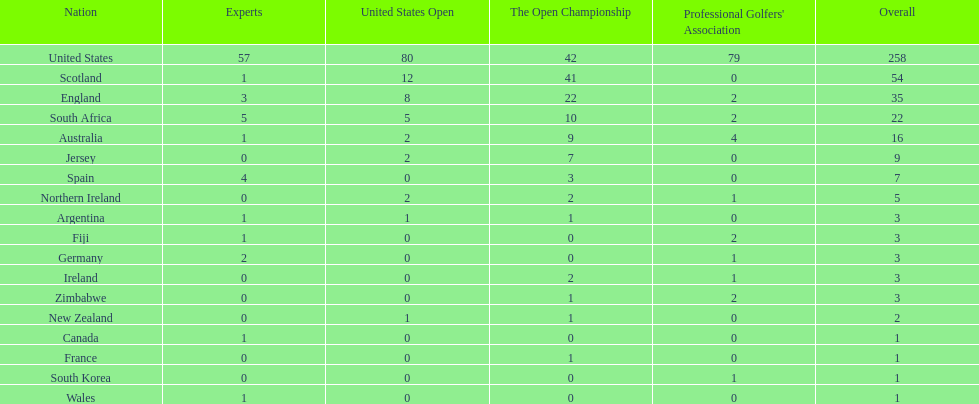Is the united stated or scotland better? United States. 